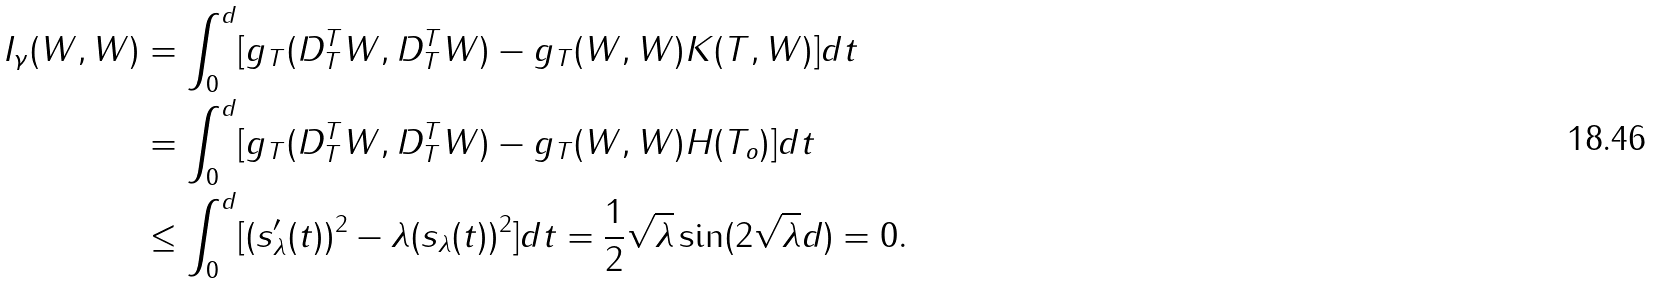<formula> <loc_0><loc_0><loc_500><loc_500>I _ { \gamma } ( W , W ) & = \int _ { 0 } ^ { d } [ g _ { T } ( D _ { T } ^ { T } W , D _ { T } ^ { T } W ) - g _ { T } ( W , W ) K ( T , W ) ] d t \\ & = \int _ { 0 } ^ { d } [ g _ { T } ( D _ { T } ^ { T } W , D _ { T } ^ { T } W ) - g _ { T } ( W , W ) H ( T _ { o } ) ] d t \\ & \leq \int _ { 0 } ^ { d } [ ( s _ { \lambda } ^ { \prime } ( t ) ) ^ { 2 } - \lambda ( s _ { \lambda } ( t ) ) ^ { 2 } ] d t = \frac { 1 } { 2 } \sqrt { \lambda } \sin ( 2 \sqrt { \lambda } d ) = 0 .</formula> 